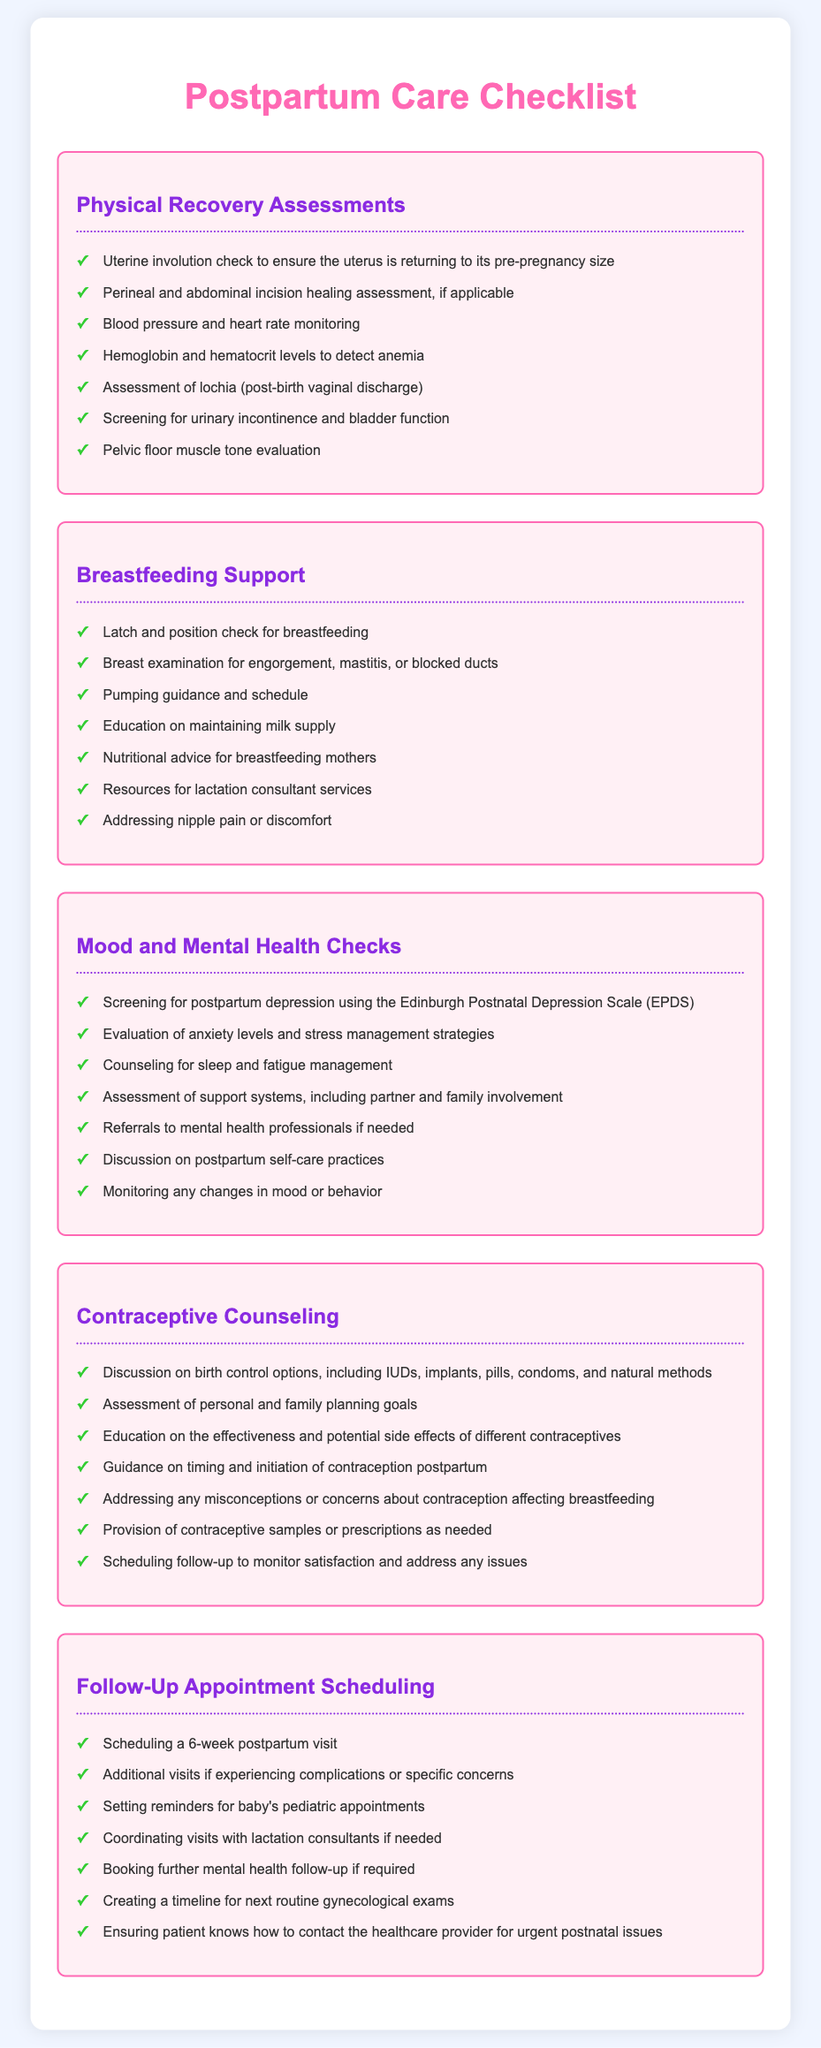What is the first assessment in Physical Recovery? The first assessment listed in Physical Recovery Assessments is the uterine involution check to ensure the uterus is returning to its pre-pregnancy size.
Answer: Uterine involution check How many points are listed under Breastfeeding Support? There are a total of six points listed under Breastfeeding Support.
Answer: 6 What scale is used for screening postpartum depression? The Edinburgh Postnatal Depression Scale (EPDS) is used for screening postpartum depression.
Answer: Edinburgh Postnatal Depression Scale (EPDS) Which contraceptive method is not mentioned in the Contraceptive Counseling section? Contraceptive methods such as diaphgrams are not mentioned in the Contraceptive Counseling section.
Answer: Diaphragm What is the time frame for the follow-up appointment scheduling? The follow-up appointment scheduling indicates a 6-week postpartum visit.
Answer: 6 weeks 